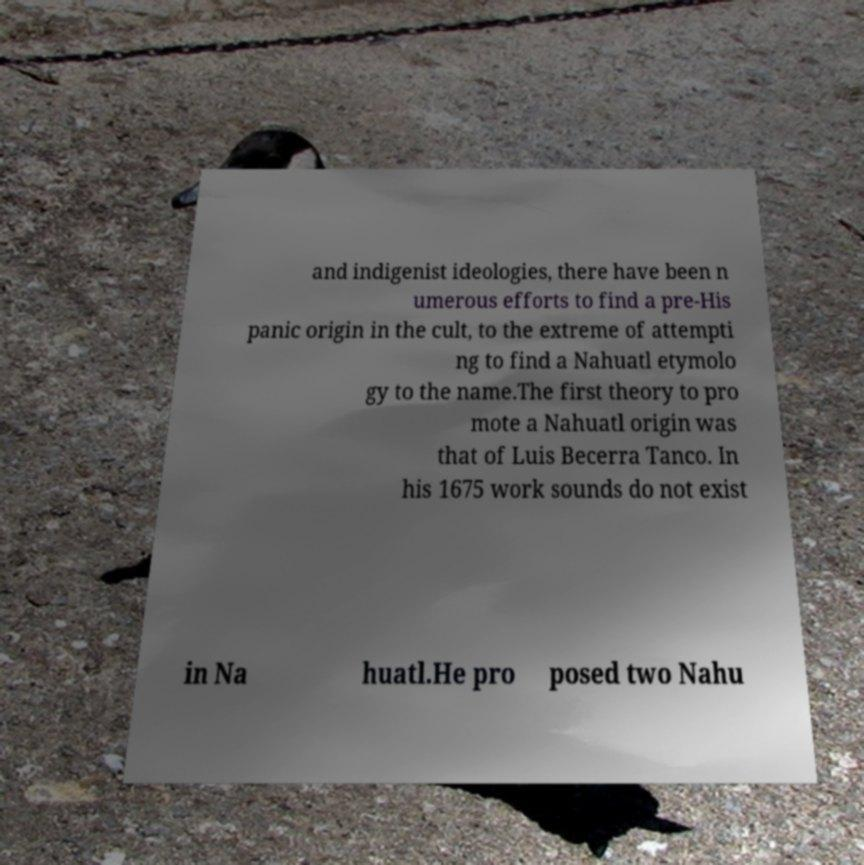Can you read and provide the text displayed in the image?This photo seems to have some interesting text. Can you extract and type it out for me? and indigenist ideologies, there have been n umerous efforts to find a pre-His panic origin in the cult, to the extreme of attempti ng to find a Nahuatl etymolo gy to the name.The first theory to pro mote a Nahuatl origin was that of Luis Becerra Tanco. In his 1675 work sounds do not exist in Na huatl.He pro posed two Nahu 